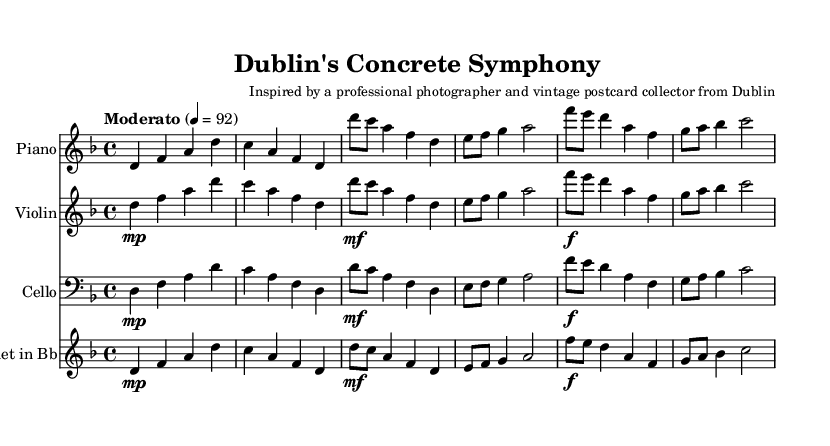What is the key signature of this music? The key signature is indicated by the key signature at the beginning of the staff. Here, it shows one flat, which corresponds to D minor.
Answer: D minor What is the time signature of the piece? The time signature appears at the beginning of the score. It is written as 4/4, meaning there are four beats per measure, and a quarter note gets one beat.
Answer: 4/4 What is the tempo marking shown in the music? The tempo marking is written directly above the staff, stating "Moderato" with a metronome marking of 4 = 92, indicating a moderate speed.
Answer: Moderato, 92 Which instruments are featured in this piece? The instruments are named above each staff in the score. They are Piano, Violin, Cello, and Clarinet in Bb.
Answer: Piano, Violin, Cello, Clarinet in Bb How many measures are there in the piano part? Counting the measures in the piano part, each set of notes separated by vertical lines represents a measure. Here, there are a total of 6 measures.
Answer: 6 Which instrument plays the highest pitch in the score? By comparing the ranges of the instruments written in the score, the Violin plays the highest pitch. The lines and spaces used indicate a higher register than the Piano, Cello, and Clarinet parts.
Answer: Violin What dynamic markings are present in the sheet music? The dynamic markings appear under the notes, showing 'mp' (mezzo-piano) and 'f' (forte) in various places. These dictate how loudly to play the notes.
Answer: mp, f 